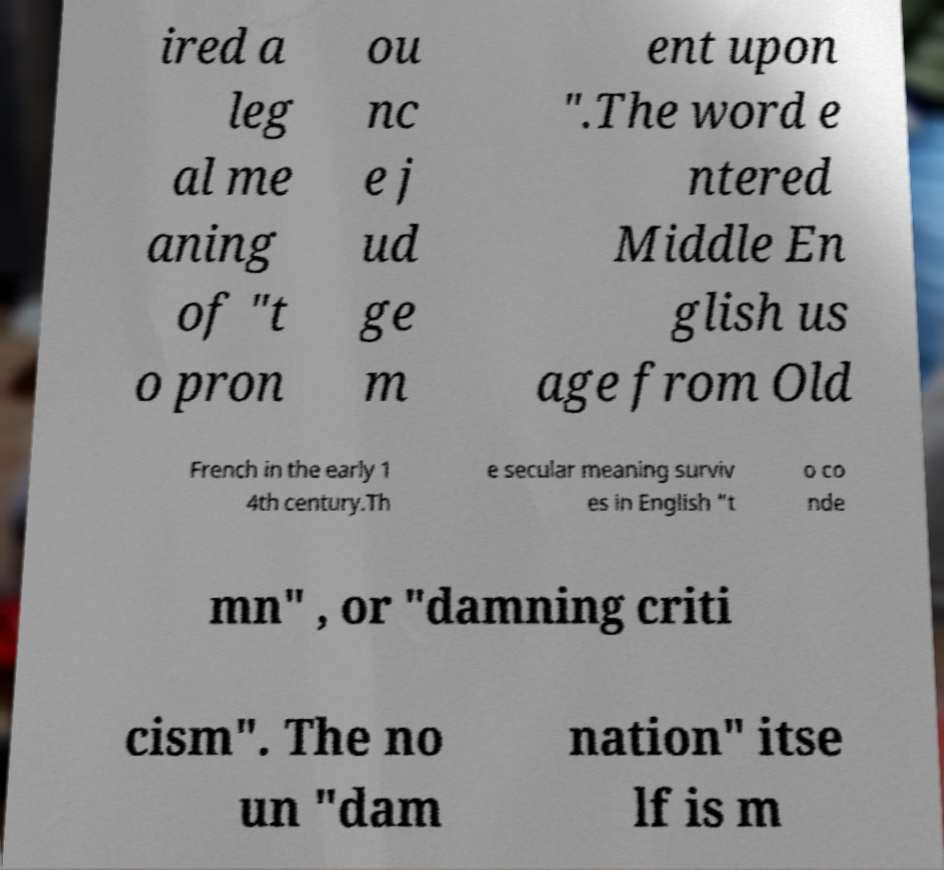Can you read and provide the text displayed in the image?This photo seems to have some interesting text. Can you extract and type it out for me? ired a leg al me aning of "t o pron ou nc e j ud ge m ent upon ".The word e ntered Middle En glish us age from Old French in the early 1 4th century.Th e secular meaning surviv es in English "t o co nde mn" , or "damning criti cism". The no un "dam nation" itse lf is m 